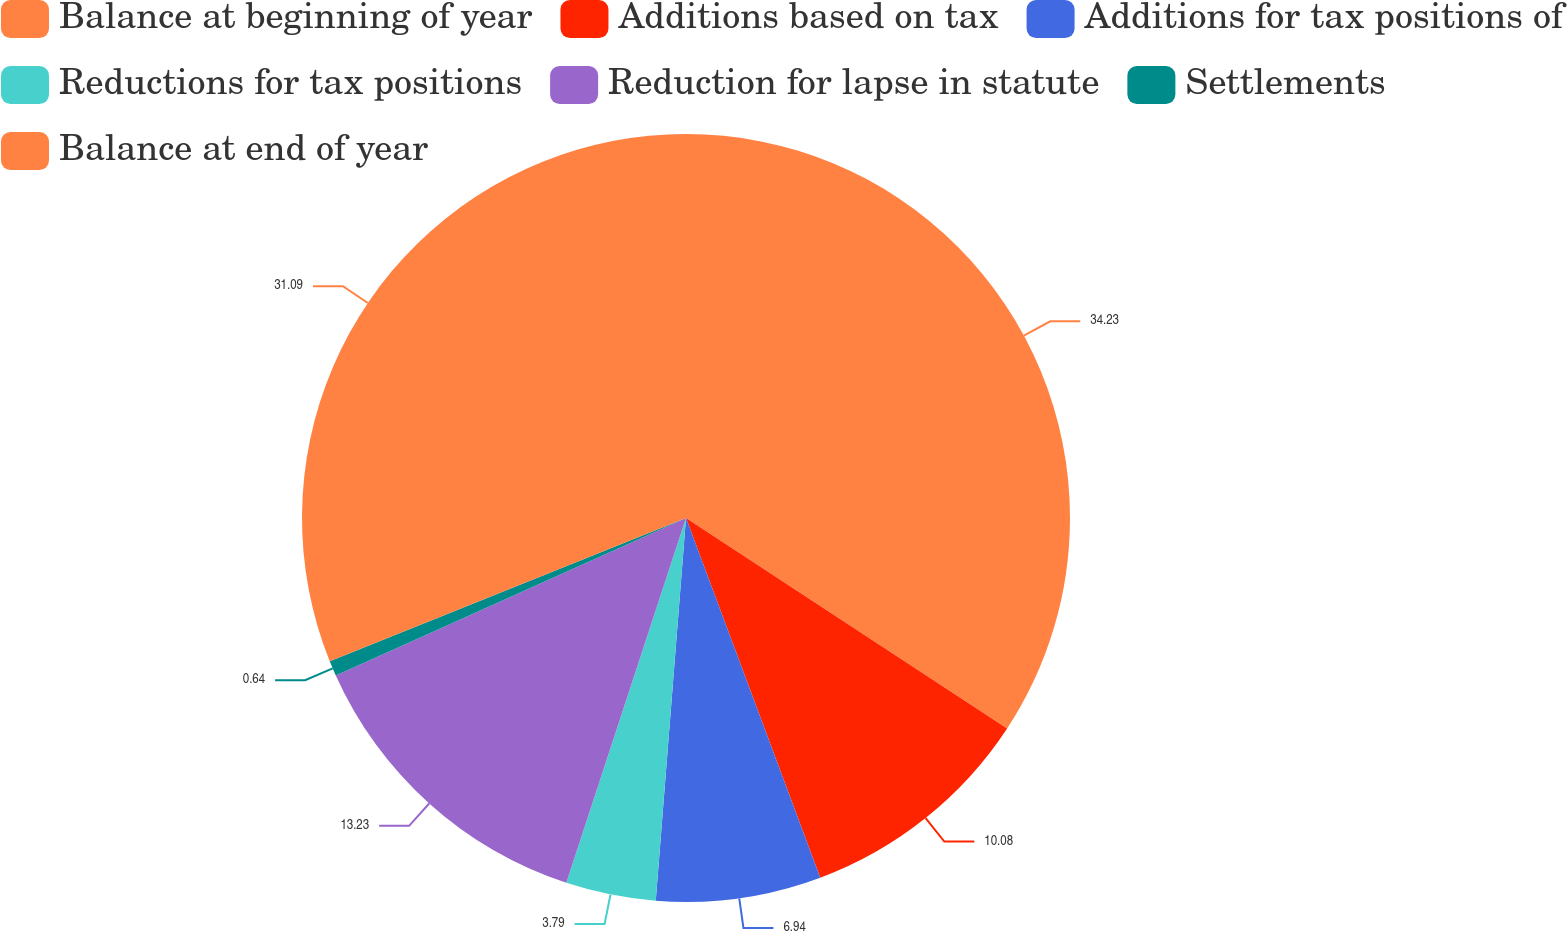Convert chart to OTSL. <chart><loc_0><loc_0><loc_500><loc_500><pie_chart><fcel>Balance at beginning of year<fcel>Additions based on tax<fcel>Additions for tax positions of<fcel>Reductions for tax positions<fcel>Reduction for lapse in statute<fcel>Settlements<fcel>Balance at end of year<nl><fcel>34.24%<fcel>10.08%<fcel>6.94%<fcel>3.79%<fcel>13.23%<fcel>0.64%<fcel>31.09%<nl></chart> 